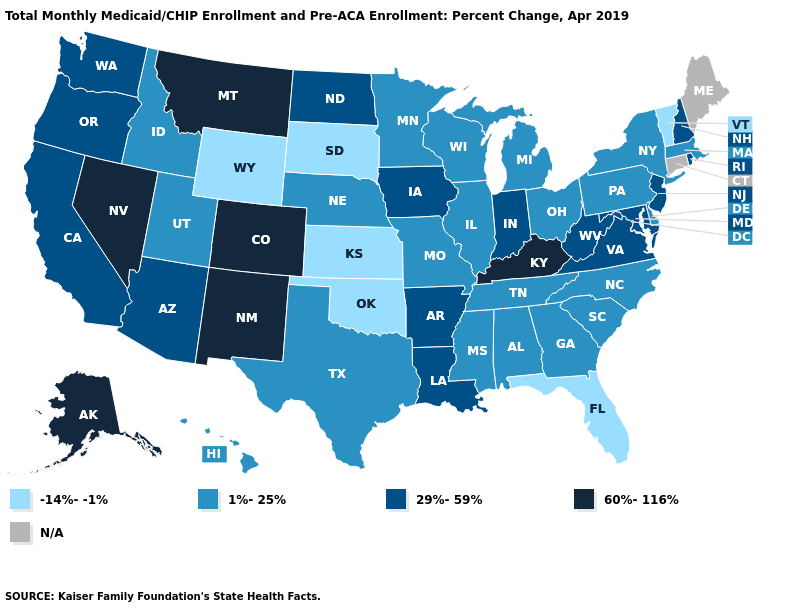Which states have the lowest value in the USA?
Keep it brief. Florida, Kansas, Oklahoma, South Dakota, Vermont, Wyoming. Name the states that have a value in the range 60%-116%?
Be succinct. Alaska, Colorado, Kentucky, Montana, Nevada, New Mexico. Does the first symbol in the legend represent the smallest category?
Keep it brief. Yes. Does the first symbol in the legend represent the smallest category?
Short answer required. Yes. Does Nevada have the highest value in the USA?
Keep it brief. Yes. What is the value of Nebraska?
Write a very short answer. 1%-25%. What is the lowest value in states that border Virginia?
Quick response, please. 1%-25%. What is the highest value in states that border Nebraska?
Keep it brief. 60%-116%. Among the states that border New York , does Vermont have the lowest value?
Write a very short answer. Yes. What is the highest value in states that border North Carolina?
Quick response, please. 29%-59%. Name the states that have a value in the range -14%--1%?
Give a very brief answer. Florida, Kansas, Oklahoma, South Dakota, Vermont, Wyoming. Name the states that have a value in the range N/A?
Concise answer only. Connecticut, Maine. What is the value of Washington?
Short answer required. 29%-59%. How many symbols are there in the legend?
Concise answer only. 5. What is the value of Hawaii?
Give a very brief answer. 1%-25%. 